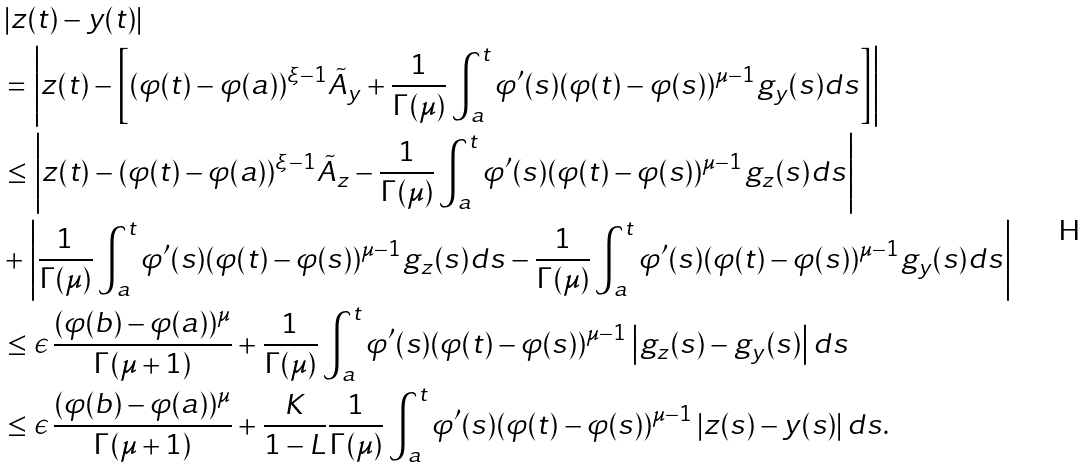Convert formula to latex. <formula><loc_0><loc_0><loc_500><loc_500>& \left | z ( t ) - y ( t ) \right | \\ & = \left | z ( t ) - \left [ ( \varphi ( t ) - \varphi ( a ) ) ^ { \xi - 1 } \tilde { A } _ { y } + \frac { 1 } { \Gamma ( \mu ) } \int _ { a } ^ { t } \varphi ^ { \prime } ( s ) ( \varphi ( t ) - \varphi ( s ) ) ^ { \mu - 1 } g _ { y } ( s ) d s \right ] \right | \\ & \leq \left | z ( t ) - ( \varphi ( t ) - \varphi ( a ) ) ^ { \xi - 1 } \tilde { A } _ { z } - \frac { 1 } { \Gamma ( \mu ) } \int _ { a } ^ { t } \varphi ^ { \prime } ( s ) ( \varphi ( t ) - \varphi ( s ) ) ^ { \mu - 1 } g _ { z } ( s ) d s \right | \\ & + \left | \frac { 1 } { \Gamma ( \mu ) } \int _ { a } ^ { t } \varphi ^ { \prime } ( s ) ( \varphi ( t ) - \varphi ( s ) ) ^ { \mu - 1 } g _ { z } ( s ) d s - \frac { 1 } { \Gamma ( \mu ) } \int _ { a } ^ { t } \varphi ^ { \prime } ( s ) ( \varphi ( t ) - \varphi ( s ) ) ^ { \mu - 1 } g _ { y } ( s ) d s \right | \\ & \leq \epsilon \, \frac { ( \varphi ( b ) - \varphi ( a ) ) ^ { \mu } } { \Gamma ( \mu + 1 ) } + \frac { 1 } { \Gamma ( \mu ) } \int _ { a } ^ { t } \varphi ^ { \prime } ( s ) ( \varphi ( t ) - \varphi ( s ) ) ^ { \mu - 1 } \left | g _ { z } ( s ) - g _ { y } ( s ) \right | d s \\ & \leq \epsilon \, \frac { ( \varphi ( b ) - \varphi ( a ) ) ^ { \mu } } { \Gamma ( \mu + 1 ) } + \frac { K } { 1 - L } \frac { 1 } { \Gamma ( \mu ) } \int _ { a } ^ { t } \varphi ^ { \prime } ( s ) ( \varphi ( t ) - \varphi ( s ) ) ^ { \mu - 1 } \left | z ( s ) - y ( s ) \right | d s .</formula> 